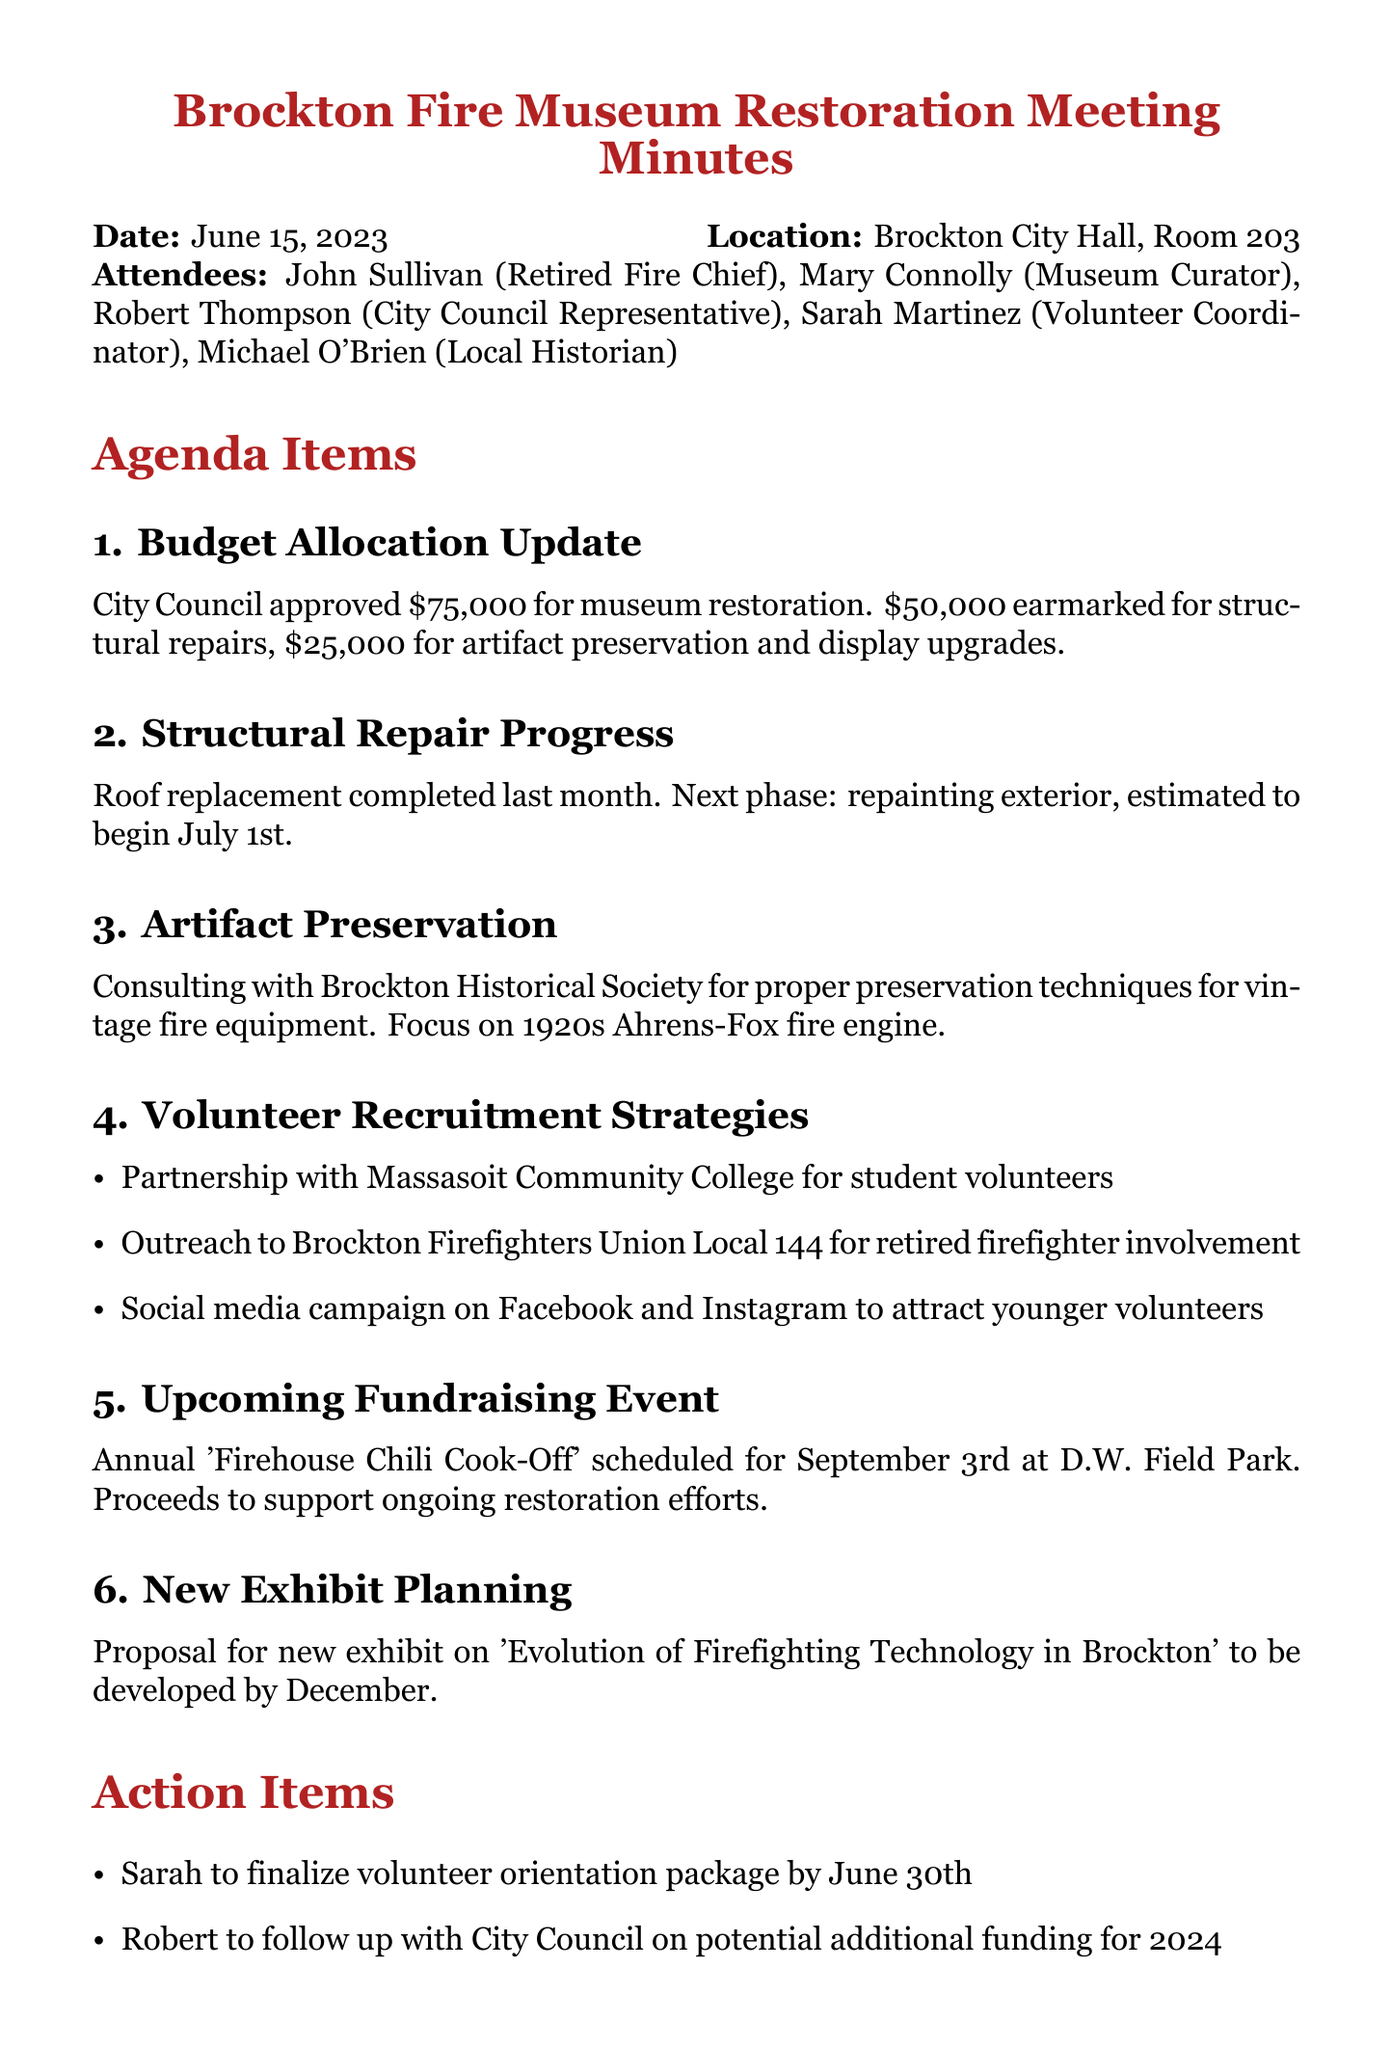What is the meeting date? The meeting date is explicitly stated in the document under the date section.
Answer: June 15, 2023 How much was approved for museum restoration? The budget allocation update mentions the total amount approved for the museum restoration.
Answer: $75,000 What is one strategy for volunteer recruitment? The document lists various strategies for volunteer recruitment; one of them is mentioned under that section.
Answer: Partnership with Massasoit Community College for student volunteers Who is responsible for finalizing the volunteer orientation package? The action items section specifies who is tasked with finalizing the volunteer orientation package.
Answer: Sarah When is the 'Firehouse Chili Cook-Off' scheduled? The document includes the date of the fundraising event scheduled for the museum.
Answer: September 3rd What artifact is the focus of preservation efforts? The artifact preservation section details which item is being preserved.
Answer: 1920s Ahrens-Fox fire engine What is the next phase of structural repairs? The document outlines the upcoming repair phase after the roof replacement.
Answer: Repainting exterior What is the location of the meeting? The location of the meeting is clearly mentioned in the header of the document.
Answer: Brockton City Hall, Room 203 